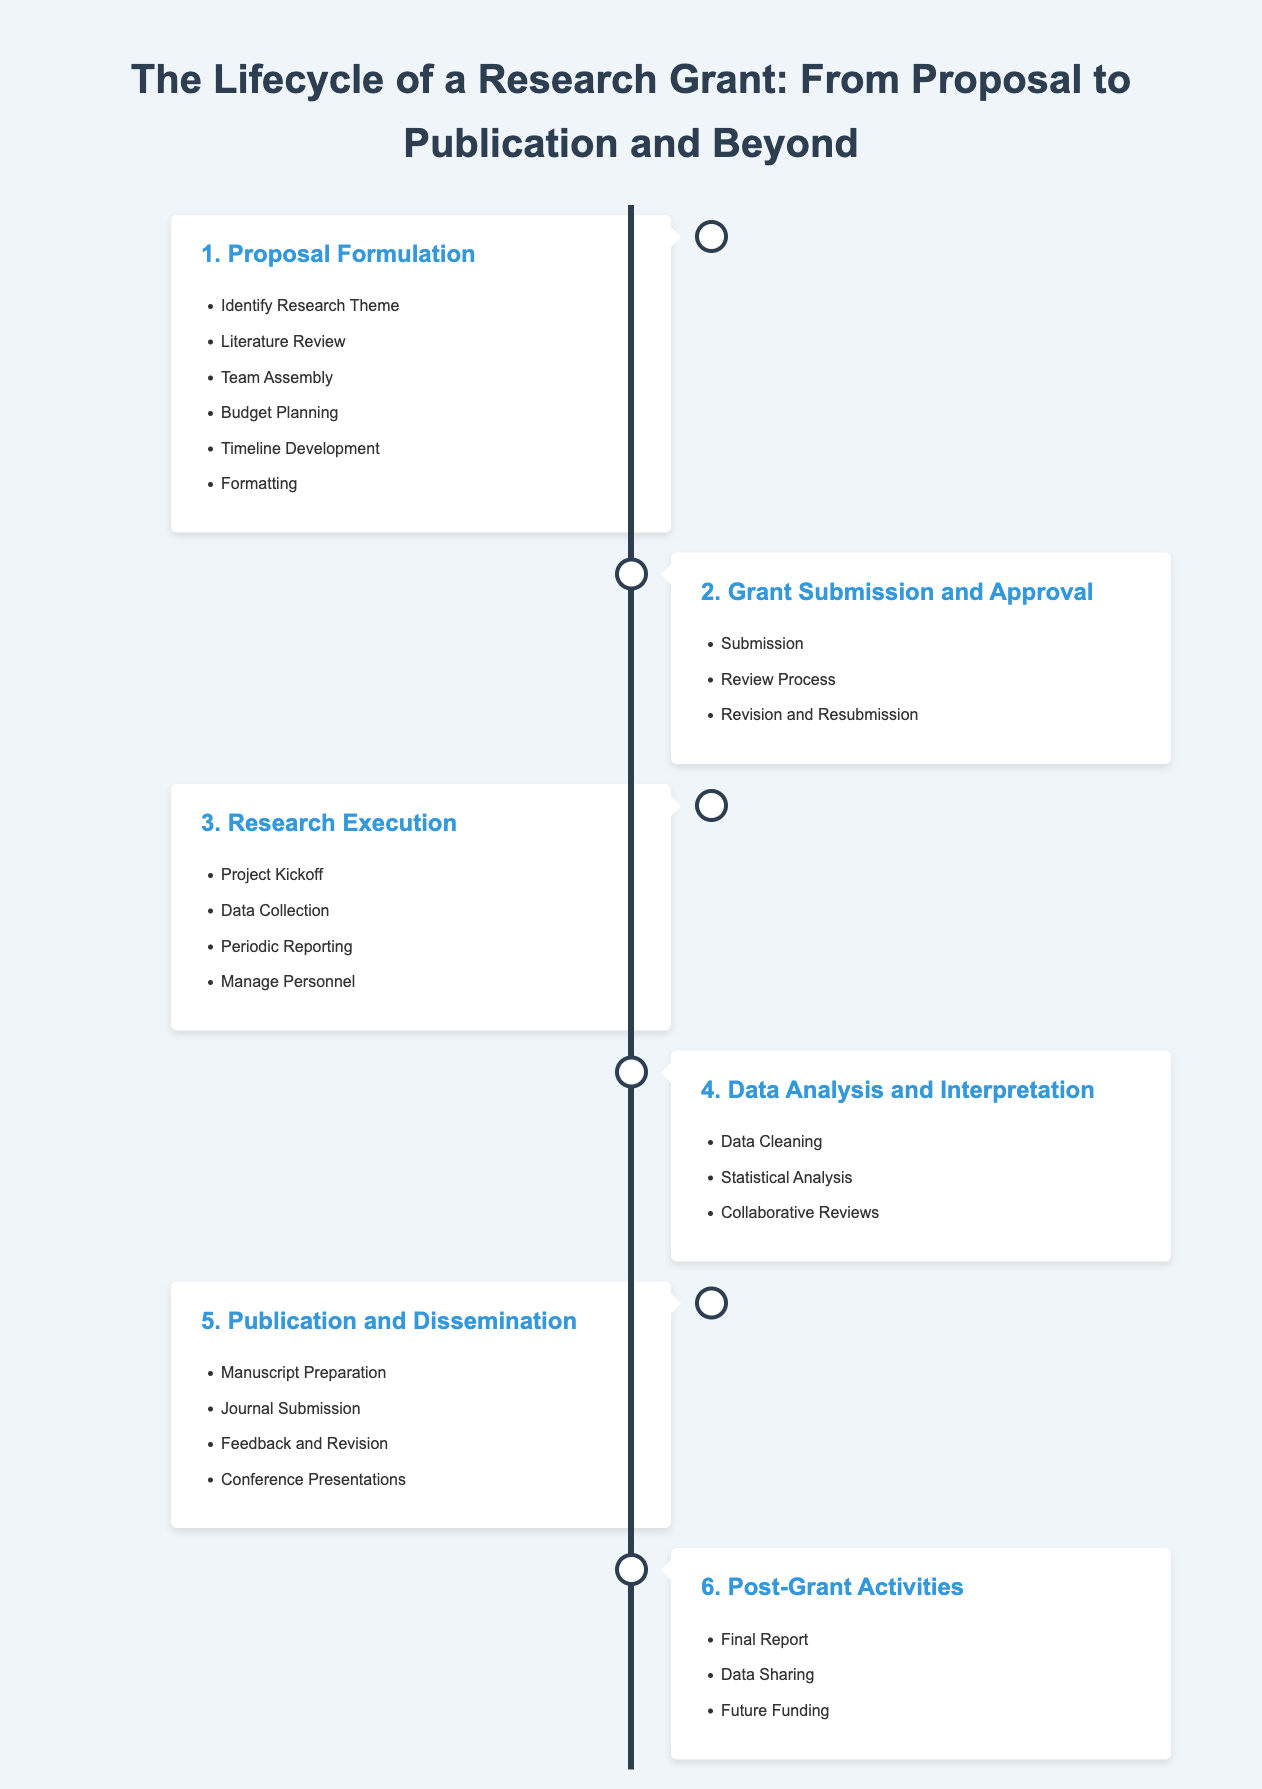What is the first step in the lifecycle of a research grant? The first step outlined in the infographic is "Proposal Formulation."
Answer: Proposal Formulation How many steps are in the research grant lifecycle? The infographic lists a total of six steps in the research grant lifecycle.
Answer: Six What is included in the "Research Execution" phase? The "Research Execution" phase includes "Project Kickoff," "Data Collection," "Periodic Reporting," and "Manage Personnel."
Answer: Project Kickoff, Data Collection, Periodic Reporting, Manage Personnel What is the last step mentioned in the infographic? The last step outlined is "Post-Grant Activities."
Answer: Post-Grant Activities Which activity is highlighted under "Publication and Dissemination"? "Manuscript Preparation" is one of the activities highlighted under "Publication and Dissemination."
Answer: Manuscript Preparation How does the timeline visually represent the phases? The timeline uses two sides (left and right) to create a visual flow of phases, alternating with circles indicating key steps.
Answer: Alternating sides with circles What is the primary theme of this infographic? The primary theme of this infographic is the lifecycle of a research grant, covering the journey from proposal to publication and beyond.
Answer: Lifecycle of a research grant What comes immediately after "Grant Submission and Approval"? Immediately after "Grant Submission and Approval," the next step is "Research Execution."
Answer: Research Execution What key aspect is part of the "Data Analysis and Interpretation" step? "Statistical Analysis" is a key aspect of the "Data Analysis and Interpretation" step.
Answer: Statistical Analysis 